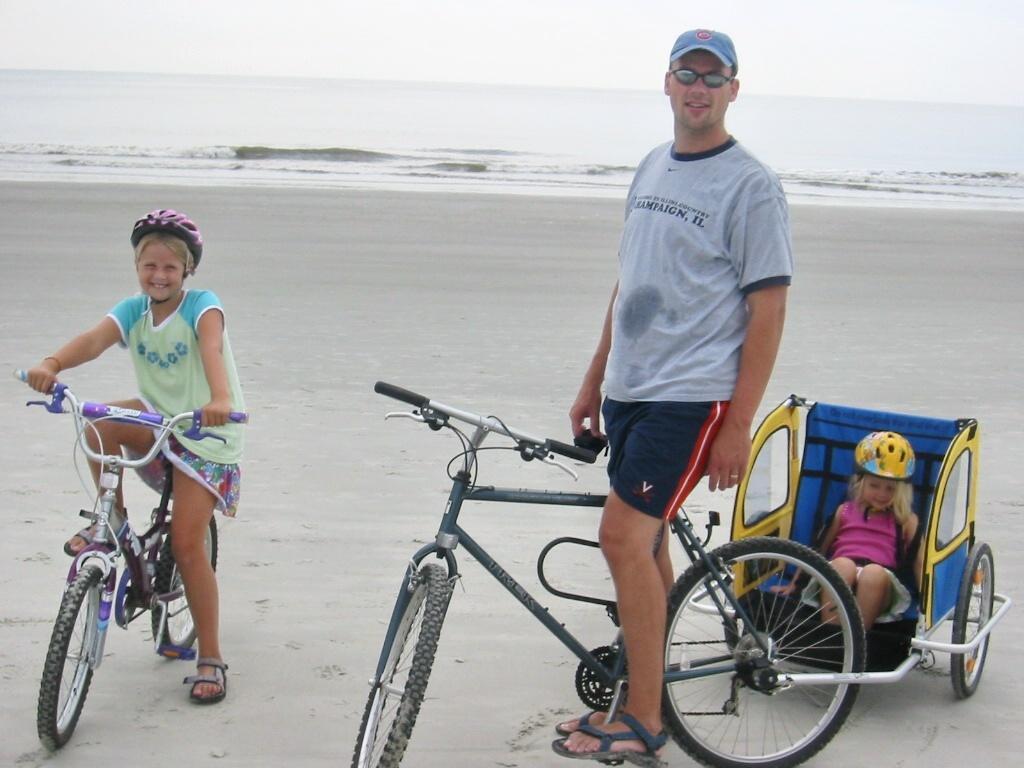Describe this image in one or two sentences. There are three members in the given picture. Both of them are cycling and the other one is in the trolley. In the background there is an ocean and sky. 